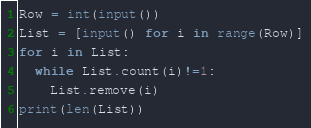<code> <loc_0><loc_0><loc_500><loc_500><_Python_>Row = int(input())
List = [input() for i in range(Row)]
for i in List:
  while List.count(i)!=1:
    List.remove(i)
print(len(List))</code> 